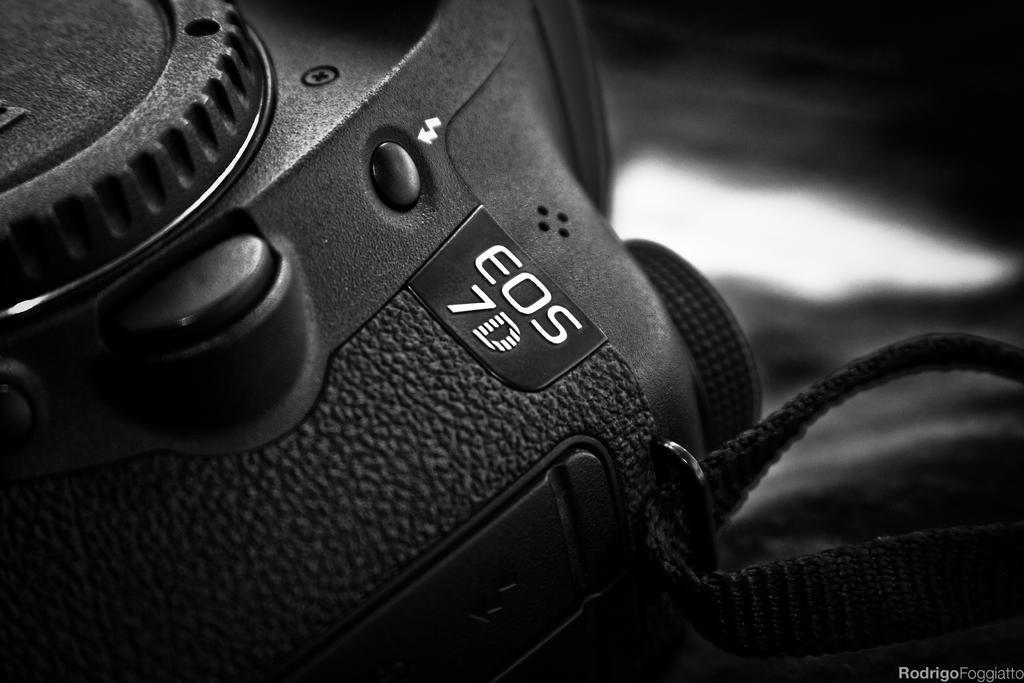What is the color scheme of the image? The image is black and white. What is the main subject of the image? The image is a zoomed in picture of an EOS 7D camera. Is there any text present in the image? Yes, there is text in the bottom right corner of the image. How many rabbits can be seen in the aftermath of the competition in the image? There are no rabbits or competition present in the image; it is a zoomed in picture of an EOS 7D camera. 